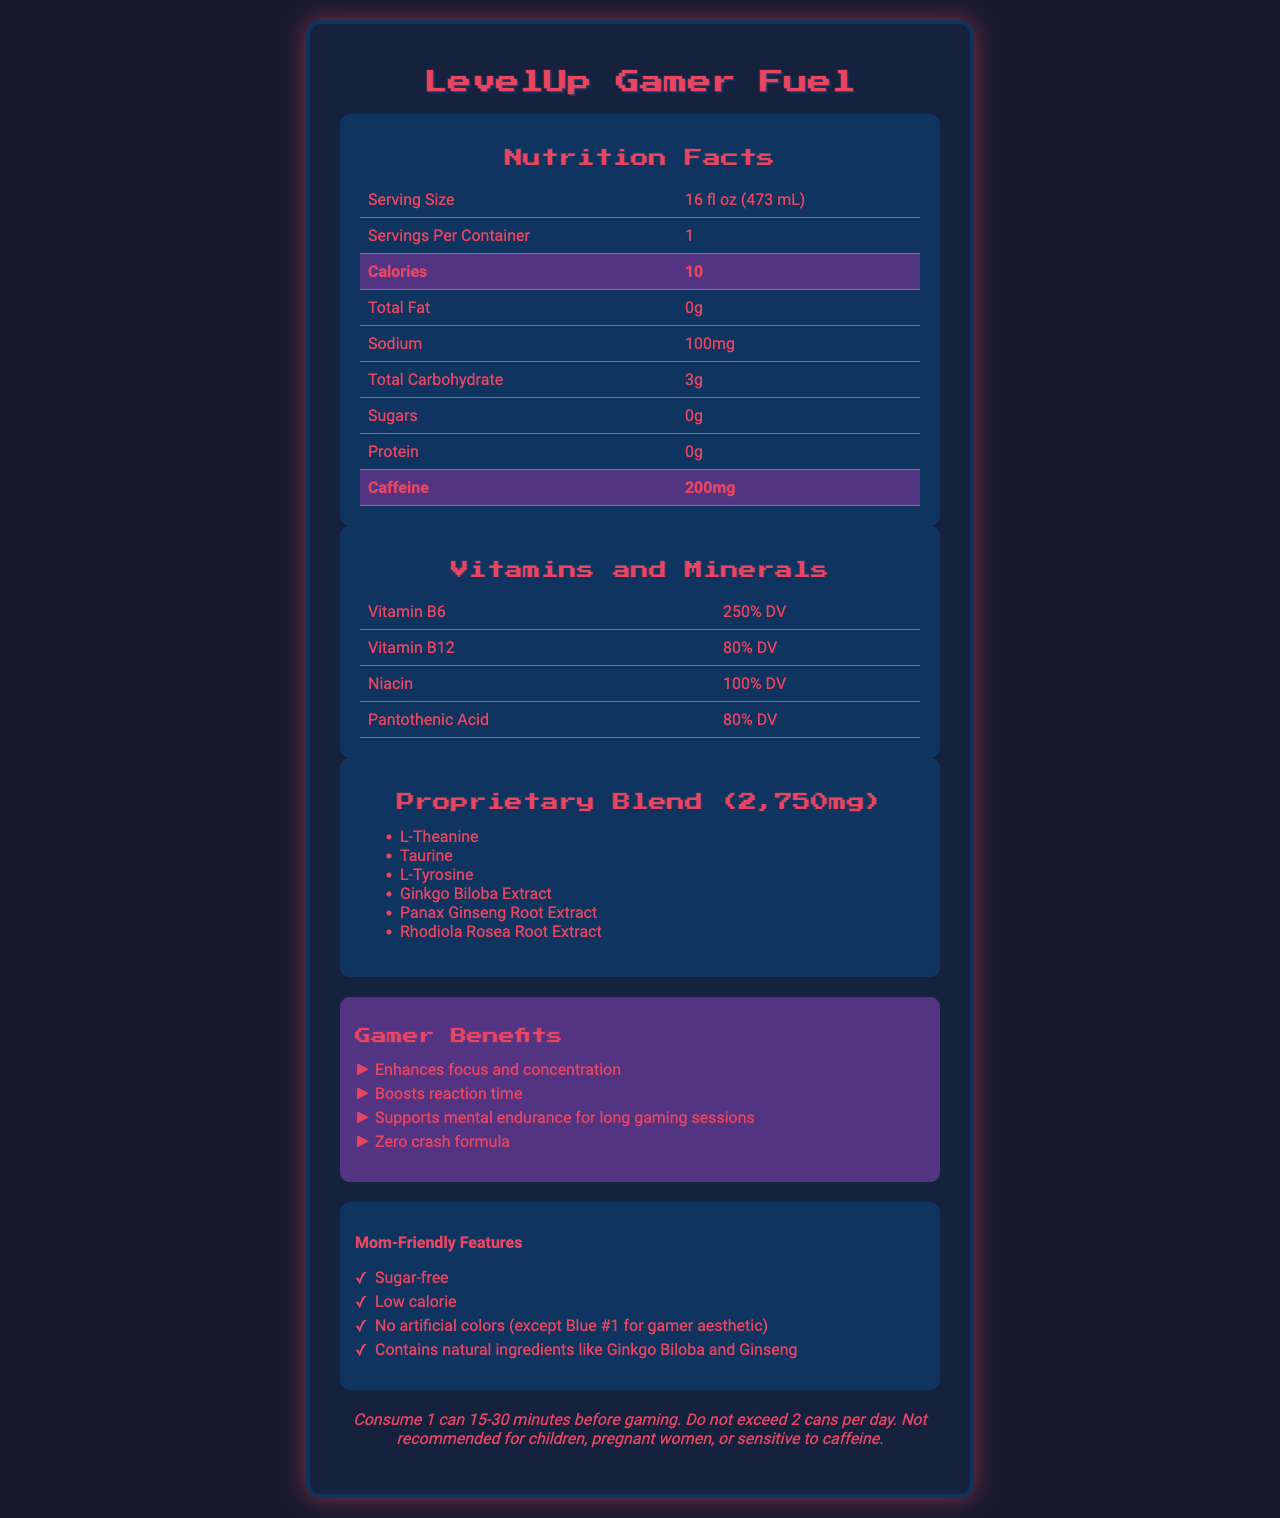what is the caffeine content in one serving? The caffeine content is explicitly mentioned as 200mg in the Nutrition Facts section.
Answer: 200mg how many calories does one can of LevelUp Gamer Fuel contain? According to the Nutrition Facts section, the calorie content is listed as 10 calories per serving.
Answer: 10 calories what are the recommended usage instructions for LevelUp Gamer Fuel? The usage instructions are detailed in a separate section at the bottom of the document.
Answer: Consume 1 can 15-30 minutes before gaming. Do not exceed 2 cans per day. Not recommended for children, pregnant women, or sensitive to caffeine. which vitamins and minerals are present in the drink? These vitamins and minerals are listed under the Vitamins and Minerals section along with their daily values.
Answer: Vitamin B6, Vitamin B12, Niacin, Pantothenic Acid what ingredients are included in the proprietary blend? The proprietary blend ingredients are listed under the Proprietary Blend section.
Answer: L-Theanine, Taurine, L-Tyrosine, Ginkgo Biloba Extract, Panax Ginseng Root Extract, Rhodiola Rosea Root Extract what is the purpose of LevelUp Gamer Fuel? A. Weight loss B. Enhancing gaming performance C. Muscle building D. Sleep aid The claims of enhancing focus, boosting reaction time, and supporting mental endurance for long gaming sessions indicate that it is aimed at enhancing gaming performance.
Answer: B which ingredient is used for the gamer aesthetic? A. Sucralose B. FD&C Blue #1 C. Citric Acid D. Taurine FD&C Blue #1 is mentioned specifically for the gamer aesthetic under "Mom-Friendly Features".
Answer: B is LevelUp Gamer Fuel sugar-free? The document states that it is sugar-free in both the Nutrition Facts and "Mom-Friendly Features" sections.
Answer: Yes does the product contain any natural ingredients? The document lists natural ingredients like Ginkgo Biloba and Ginseng under "Mom-Friendly Features".
Answer: Yes is it safe for children to consume LevelUp Gamer Fuel? The usage instructions explicitly state that it is not recommended for children.
Answer: No what additional benefits does the drink offer specifically for moms? These benefits are listed under the "Mom-Friendly Features" section.
Answer: Sugar-free, Low calorie, No artificial colors (except Blue #1), Contains natural ingredients like Ginkgo Biloba and Ginseng how much sodium is in one serving of LevelUp Gamer Fuel? The sodium content is listed as 100mg in the Nutrition Facts section.
Answer: 100mg what is a potential allergen concern for this product? The allergen information is mentioned in the document.
Answer: Manufactured in a facility that also processes milk, soy, and tree nuts summarize the main idea of the nutrition facts label for LevelUp Gamer Fuel. The document provides detailed information about the nutritional content, benefits for gamers, specific features for moms, and safety instructions of LevelUp Gamer Fuel.
Answer: LevelUp Gamer Fuel is a low-calorie, sugar-free energy drink designed to enhance focus, reaction time, and mental endurance for gamers. It contains 200mg of caffeine, various vitamins and minerals, and a proprietary blend of ingredients known to boost cognitive function. It features natural ingredients and is manufactured in a facility that processes common allergens. The drink includes instructions for safe consumption and highlights several benefits for moms. how much L-Theanine is in the drink? The document lists L-Theanine as an ingredient in the proprietary blend but does not specify its individual quantity.
Answer: Not enough information can you list all preservatives used in LevelUp Gamer Fuel? These preservatives are listed under the "other ingredients" section of the document.
Answer: Potassium Sorbate, Potassium Benzoate 